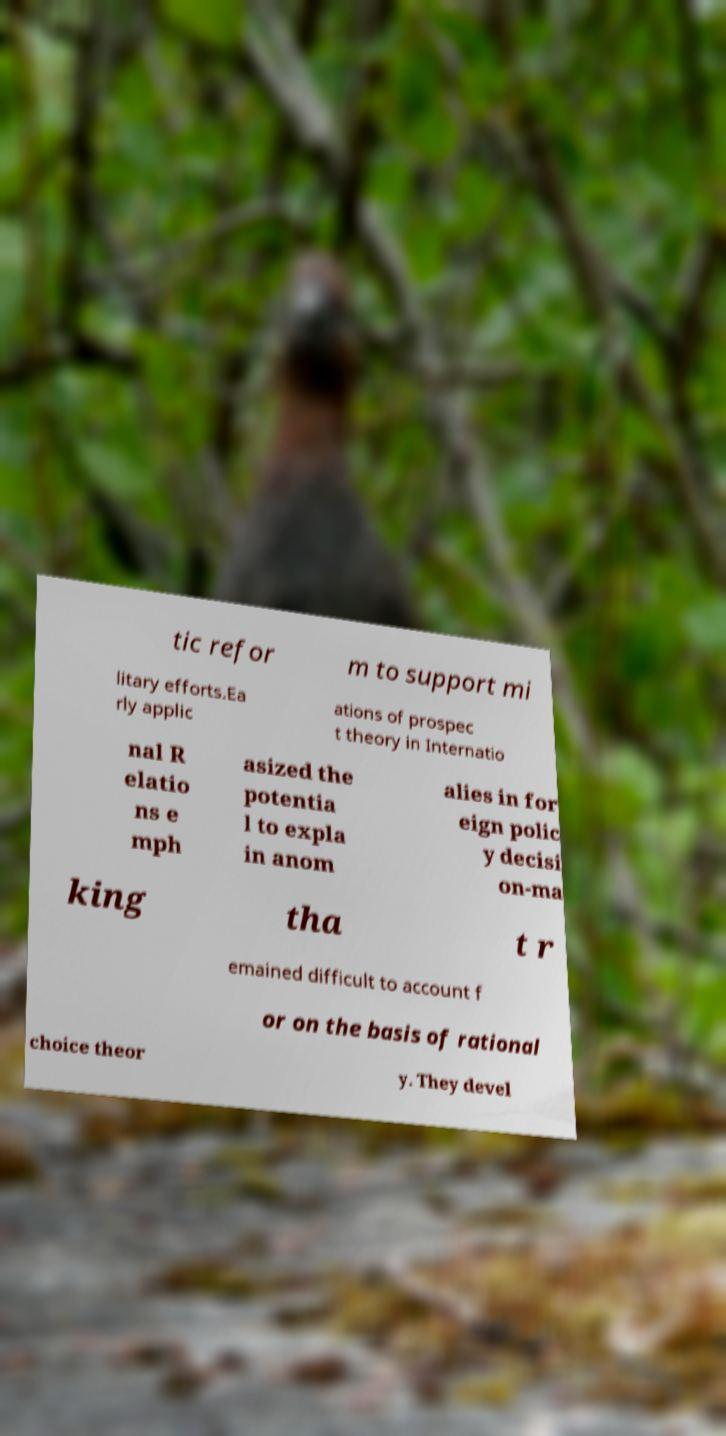Can you read and provide the text displayed in the image?This photo seems to have some interesting text. Can you extract and type it out for me? tic refor m to support mi litary efforts.Ea rly applic ations of prospec t theory in Internatio nal R elatio ns e mph asized the potentia l to expla in anom alies in for eign polic y decisi on-ma king tha t r emained difficult to account f or on the basis of rational choice theor y. They devel 